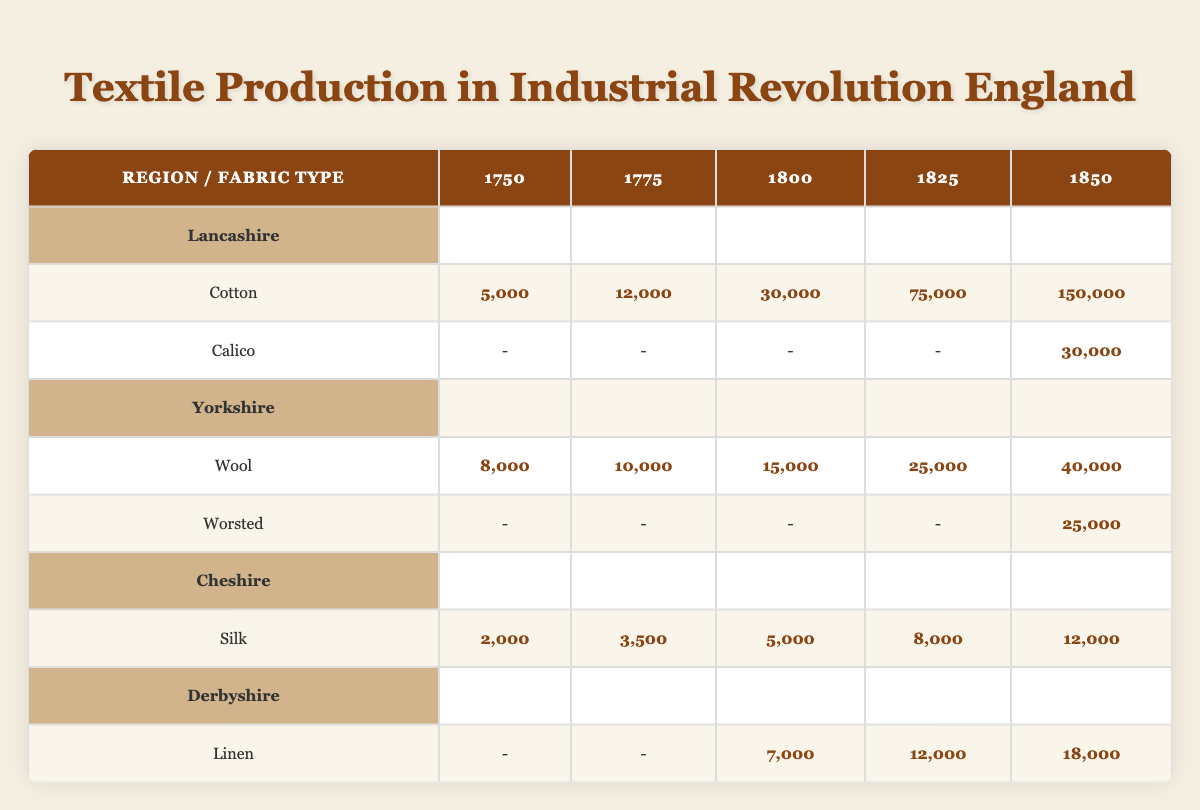What was the production output of Cotton in Lancashire in 1825? In the table, we look under the Lancashire region for the Cotton fabric type in the year 1825. The output listed is 75,000.
Answer: 75,000 Which region produced the highest amount of Silk in 1850? To determine this, we find the output for Silk across the regions in the year 1850. The outputs are: Cheshire 12,000. No other regions produced Silk, so Cheshire produced the highest amount.
Answer: Cheshire What is the total production output of Wool from Yorkshire from 1750 to 1850? We sum the Wool outputs from Yorkshire for each year: 8,000 (1750) + 10,000 (1775) + 15,000 (1800) + 25,000 (1825) + 40,000 (1850) = 98,000.
Answer: 98,000 Was there any production of Calico in the year 1800? Looking at the table under the Calico row for the year 1800, we see a dash indicating no output. Thus, Calico was not produced in that year.
Answer: No In which year did Lancashire see the largest output for Cotton, and what was that amount? We check the Cotton output for Lancashire across the years: 5,000 (1750), 12,000 (1775), 30,000 (1800), 75,000 (1825), and 150,000 (1850). The largest output was 150,000 in 1850.
Answer: 1850, 150,000 What is the difference in production output of Linen between Derbyshire in 1800 and 1850? The output for Linen in 1800 is 7,000, and in 1850 it is 18,000. The difference is calculated as 18,000 - 7,000 = 11,000.
Answer: 11,000 Which fabric type showed production growth in every year recorded, and what was the final output? By examining the table, we see that Cotton increased its output each year in Lancashire: 5,000 (1750), 12,000 (1775), 30,000 (1800), 75,000 (1825), 150,000 (1850). Thus, Cotton showed growth every year with a final output of 150,000 in 1850.
Answer: Cotton, 150,000 How much more was the Wool output in 1850 compared to 1750 in Yorkshire? The Wool output in Yorkshire for 1850 is 40,000 and for 1750 it is 8,000. The difference is calculated as 40,000 - 8,000 = 32,000.
Answer: 32,000 Which region had no recorded output for Linen in the earlier years? Upon examining the table, we see that Derbyshire had no Linen production recorded until 1800, showing a dash for both 1750 and 1775. Thus, Derbyshire is the region with no early output.
Answer: Derbyshire 